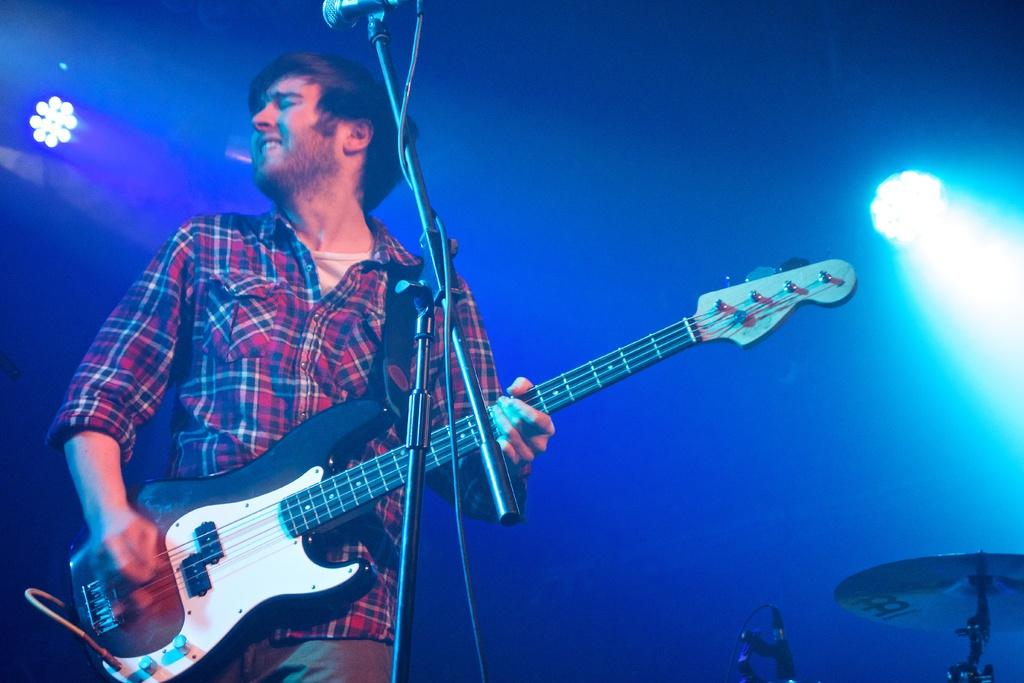What is the man in the image doing? The man is playing a guitar in the image. What musical instrument can be seen in the background of the image? There is a cymbal in the background of the image. What type of lighting is present in the background of the image? There are focus lights in the background of the image. What type of mint is the man using to play the guitar in the image? There is no mint present in the image, and the man is not using any mint to play the guitar. 